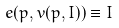<formula> <loc_0><loc_0><loc_500><loc_500>e ( p , v ( p , I ) ) \equiv I</formula> 